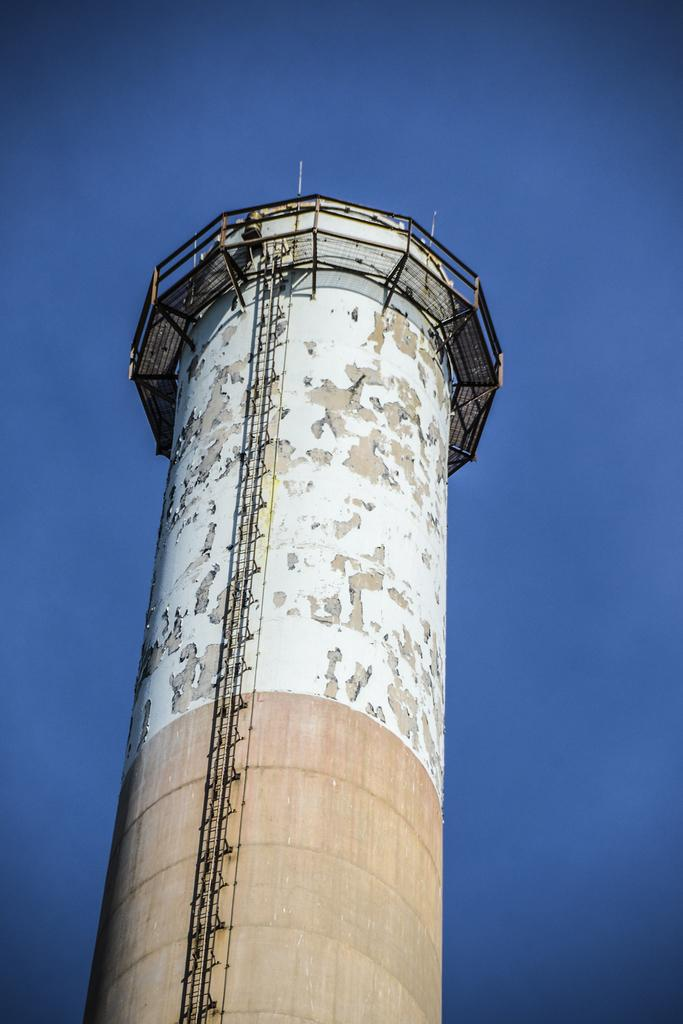What is the main subject of the image? The main subject of the image is a big tanker. Are there any specific features on the tanker? Yes, the tanker has an iron ladder. What can be seen at the top of the tanker? There is a fence at the top of the tanker. What type of card is being used to climb the tanker in the image? There is no card present in the image; the tanker has an iron ladder for climbing. Can you see the moon in the image? The image does not show the moon; it only features a big tanker with an iron ladder and a fence at the top. 